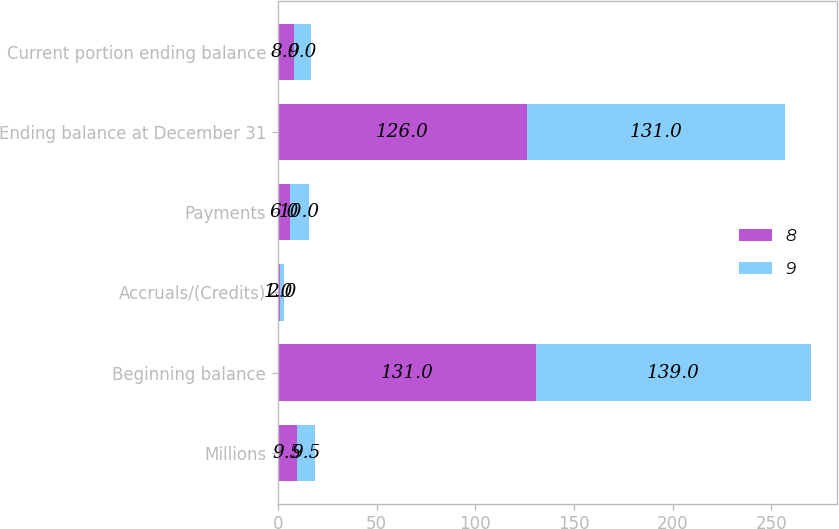<chart> <loc_0><loc_0><loc_500><loc_500><stacked_bar_chart><ecel><fcel>Millions<fcel>Beginning balance<fcel>Accruals/(Credits)<fcel>Payments<fcel>Ending balance at December 31<fcel>Current portion ending balance<nl><fcel>8<fcel>9.5<fcel>131<fcel>1<fcel>6<fcel>126<fcel>8<nl><fcel>9<fcel>9.5<fcel>139<fcel>2<fcel>10<fcel>131<fcel>9<nl></chart> 